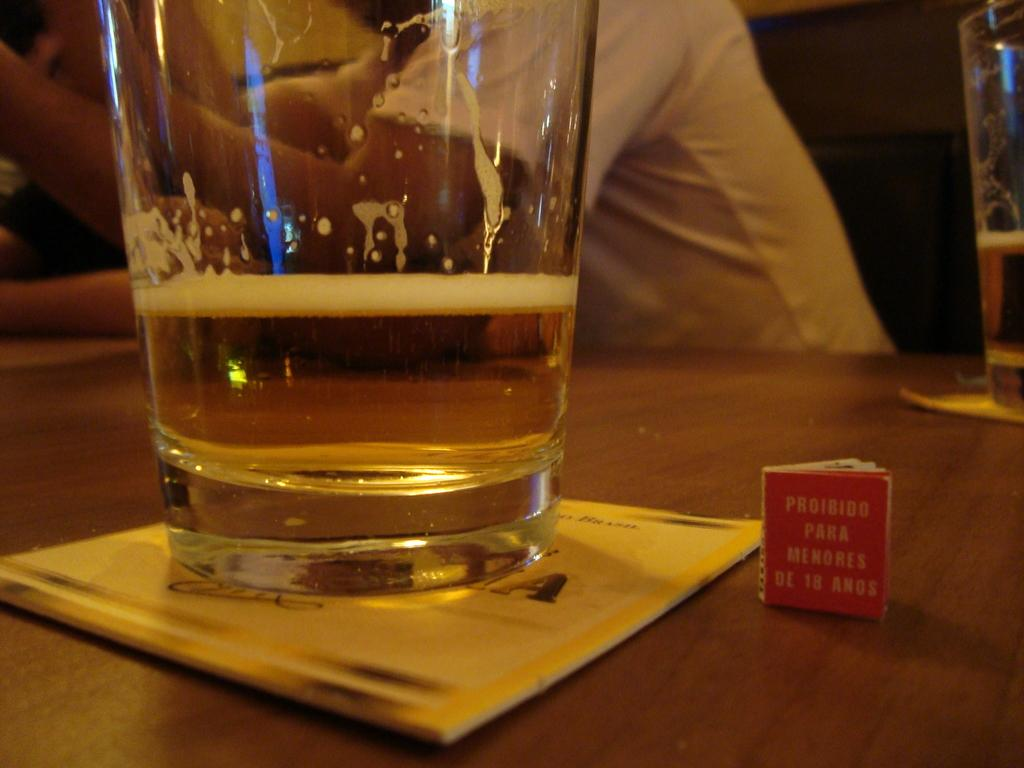<image>
Summarize the visual content of the image. A glass next to a small book with "proibido para menores de 18 anos" written on it 